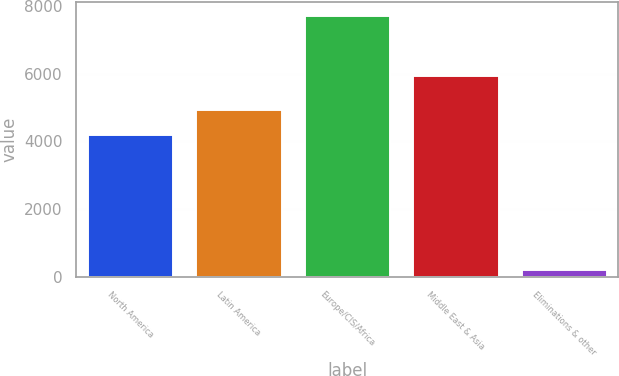<chart> <loc_0><loc_0><loc_500><loc_500><bar_chart><fcel>North America<fcel>Latin America<fcel>Europe/CIS/Africa<fcel>Middle East & Asia<fcel>Eliminations & other<nl><fcel>4217<fcel>4967.2<fcel>7737<fcel>5961<fcel>235<nl></chart> 